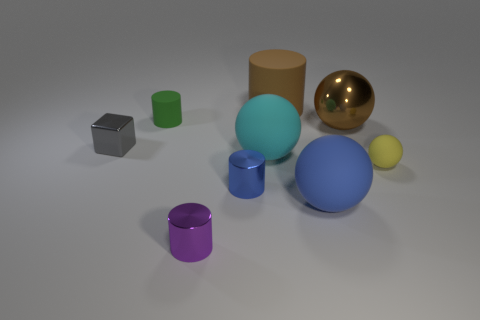Subtract 1 cylinders. How many cylinders are left? 3 Add 1 purple cylinders. How many objects exist? 10 Subtract all cylinders. How many objects are left? 5 Add 9 large gray metal things. How many large gray metal things exist? 9 Subtract 1 gray blocks. How many objects are left? 8 Subtract all red metallic spheres. Subtract all blue spheres. How many objects are left? 8 Add 1 purple things. How many purple things are left? 2 